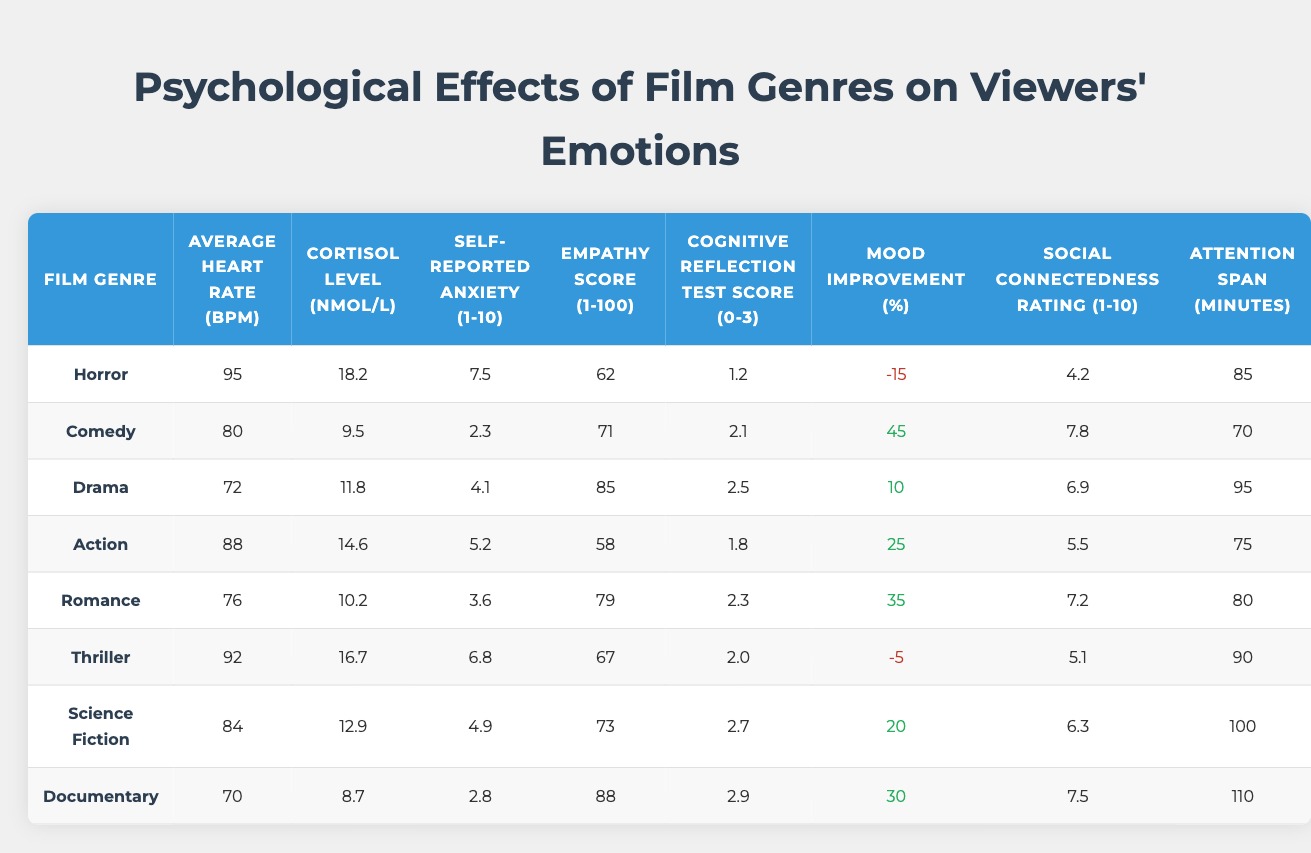What is the average heart rate for Horror films? The table lists the average heart rate for Horror films as 95 bpm.
Answer: 95 bpm Which film genre has the highest cortisol level? The table shows that Horror films have the highest cortisol level at 18.2 nmol/L.
Answer: Horror What is the empathy score for Romance films? According to the table, the empathy score for Romance films is 79.
Answer: 79 What mood improvement percentage is associated with Comedy films? The table indicates that Comedy films have a mood improvement percentage of 45%.
Answer: 45% Which film genre has the lowest self-reported anxiety? The table reveals that Comedy films have the lowest self-reported anxiety score at 2.3.
Answer: Comedy What is the average empathy score for all film genres in the table? To find the average empathy score, we add all the empathy scores: (62 + 71 + 85 + 58 + 79 + 67 + 73 + 88) = 583, and then divide by the number of genres, which is 8: 583/8 = 72.875, round to 72.9.
Answer: 72.9 Is there a correlation between the mood improvement percentage and self-reported anxiety? Yes, by looking at the table, we find that genres with higher mood improvement percentages like Comedy (45) have lower self-reported anxiety (2.3), while genres like Horror (-15) have higher anxiety (7.5). This indicates an inverse relationship.
Answer: Yes Which genre shows the largest difference in attention span between the highest and lowest? The attention spans for the genres are Action (75 minutes) and Documentary (110 minutes). The difference is 110 - 75 = 35 minutes.
Answer: 35 minutes For which genre is the social connectedness rating highest? The table shows that Comedy films have the highest social connectedness rating of 7.8.
Answer: Comedy What is the average cortisol level for the genres that score higher than 70 in empathy? The genres with an empathy score greater than 70 are Comedy (71), Drama (85), Romance (79), and Documentary (88). The cortisol levels for these genres are 9.5, 11.8, 10.2, and 8.7; average = (9.5 + 11.8 + 10.2 + 8.7) / 4 = 10.05.
Answer: 10.05 nmol/L 